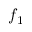Convert formula to latex. <formula><loc_0><loc_0><loc_500><loc_500>f _ { 1 }</formula> 